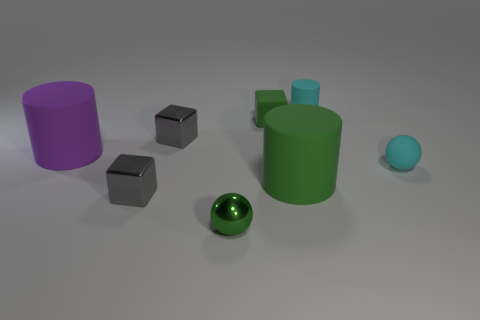What shape is the cyan object in front of the green rubber cube?
Ensure brevity in your answer.  Sphere. How many other things are the same material as the green ball?
Offer a terse response. 2. What material is the large purple cylinder?
Ensure brevity in your answer.  Rubber. What number of small things are either purple balls or gray metallic things?
Your answer should be very brief. 2. There is a tiny green rubber cube; how many purple rubber things are right of it?
Provide a short and direct response. 0. Are there any small rubber things that have the same color as the tiny cylinder?
Your response must be concise. Yes. The green thing that is the same size as the green cube is what shape?
Your answer should be compact. Sphere. What number of cyan objects are either tiny matte things or matte balls?
Give a very brief answer. 2. What number of cyan spheres are the same size as the green cube?
Your answer should be compact. 1. There is a metal thing that is the same color as the rubber block; what is its shape?
Provide a short and direct response. Sphere. 